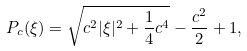<formula> <loc_0><loc_0><loc_500><loc_500>P _ { c } ( \xi ) = \sqrt { c ^ { 2 } | \xi | ^ { 2 } + \frac { 1 } { 4 } c ^ { 4 } } - \frac { c ^ { 2 } } { 2 } + 1 ,</formula> 